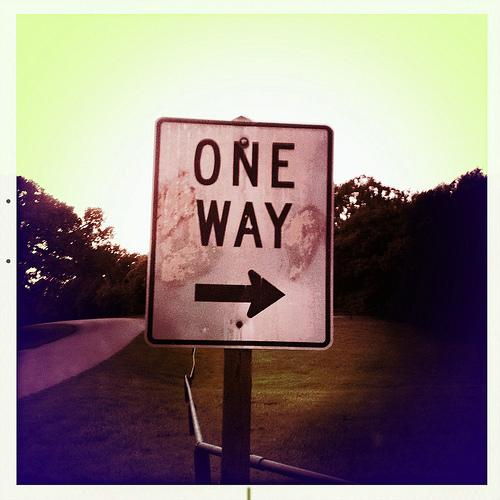How many patches of green grass are visible in the image There are nine patches of green grass in the image. What is the prominent object in the image and what does it say? The prominent object is a street sign on a pole, saying "one way." Explain the shape and colors found on the one way sign. The one way sign has a rectangular shape, with a white background, black lettering, and a black arrow. Describe the environment surrounding the one way sign. The sign is near a grassy field with trees, and there is a sidewalk by the field, and a fence in the field. What are some distinguishing features of the objects surrounding the sign such as the fence, field, and the sky? The fence has a railing, the field has green grass, and the sky is clear with a yellow sun. Identify the color of the sky and the sun in the image. The sky is clear and the sun is yellow. List all key elements in the image, including the primary object, its features, and its surroundings. One way sign on pole, black arrow and letters, white sign, wooden post, clear sky, yellow sun, green grass, leafy trees, metal fence, and metal bolts. Mention any property of the pole holding the sign. The pole holding the sign is wooden. What material is the fence made of and what is the color of the grass behind the sign? The fence is made of metal and the grass behind the sign is green. Describe the state of the sign and its different markings. The sign is white and very dirty, with black marks, black lettering, and a black arrow on it. Contemplate the impact of the car crash that shattered the sign. There's extensive information about a dirty, aged sign, but no mention of damage from a car crash. This instruction gives a false backstory for the sign's appearance and adds unrelated context. Do not miss the hidden door under the grass revealing a secret underground lair. The image has several patches of grass and a grassy field, but no mention of a door or an underground lair. It deludes the audience to look for something not present in the image. Identify the red balloon recently detached from the sign. The image contains a sign and several related elements, but there's no mention of balloons or anything related to that. Introducing a red balloon steers people away from actual existent objects in the image. Observe how the flock of birds has gathered around the sun in the sky. No, it's not mentioned in the image. Can you spot the flying purple unicorn in the distance? There is no mention of a purple unicorn or any variation of a flying creature in the image; therefore, it's misleading to suggest the existence of one. 